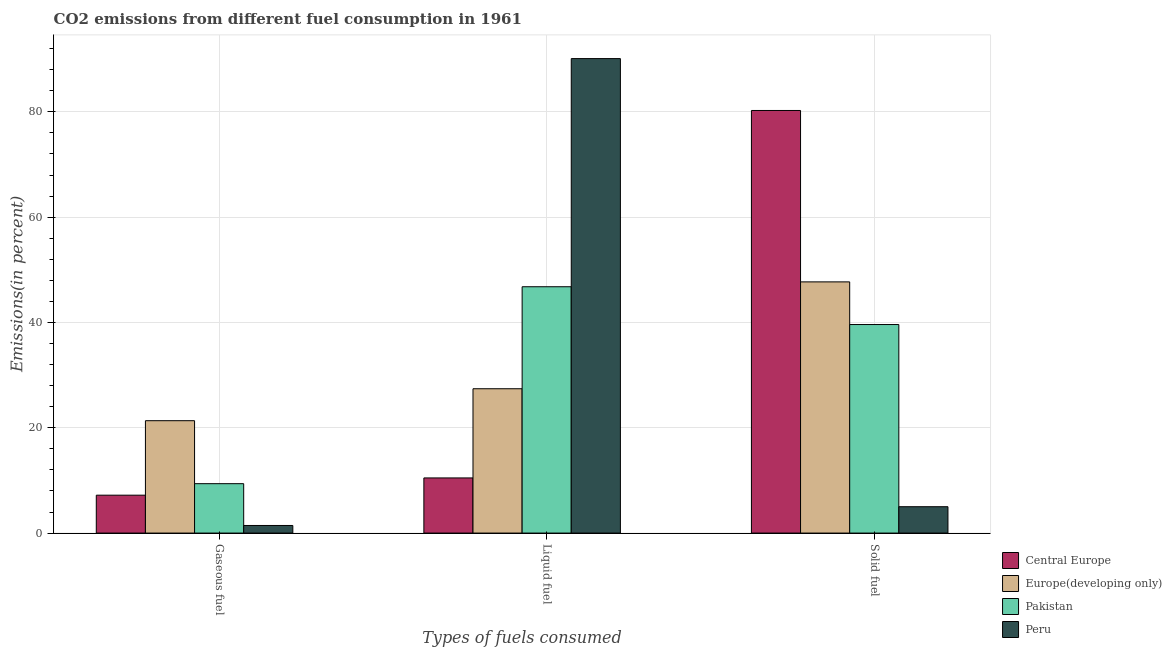How many different coloured bars are there?
Offer a terse response. 4. Are the number of bars on each tick of the X-axis equal?
Provide a short and direct response. Yes. How many bars are there on the 1st tick from the left?
Your response must be concise. 4. What is the label of the 2nd group of bars from the left?
Your answer should be compact. Liquid fuel. What is the percentage of solid fuel emission in Peru?
Make the answer very short. 5.01. Across all countries, what is the maximum percentage of solid fuel emission?
Ensure brevity in your answer.  80.26. Across all countries, what is the minimum percentage of liquid fuel emission?
Your answer should be compact. 10.47. In which country was the percentage of solid fuel emission maximum?
Your answer should be very brief. Central Europe. What is the total percentage of solid fuel emission in the graph?
Your answer should be very brief. 172.58. What is the difference between the percentage of gaseous fuel emission in Central Europe and that in Europe(developing only)?
Keep it short and to the point. -14.14. What is the difference between the percentage of solid fuel emission in Central Europe and the percentage of liquid fuel emission in Peru?
Offer a terse response. -9.85. What is the average percentage of liquid fuel emission per country?
Your response must be concise. 43.7. What is the difference between the percentage of gaseous fuel emission and percentage of solid fuel emission in Pakistan?
Your response must be concise. -30.22. What is the ratio of the percentage of gaseous fuel emission in Peru to that in Pakistan?
Your answer should be compact. 0.15. Is the difference between the percentage of liquid fuel emission in Europe(developing only) and Peru greater than the difference between the percentage of gaseous fuel emission in Europe(developing only) and Peru?
Provide a succinct answer. No. What is the difference between the highest and the second highest percentage of gaseous fuel emission?
Your answer should be compact. 11.96. What is the difference between the highest and the lowest percentage of gaseous fuel emission?
Your answer should be very brief. 19.9. What does the 4th bar from the right in Gaseous fuel represents?
Your answer should be compact. Central Europe. Is it the case that in every country, the sum of the percentage of gaseous fuel emission and percentage of liquid fuel emission is greater than the percentage of solid fuel emission?
Offer a very short reply. No. How many bars are there?
Offer a terse response. 12. How many countries are there in the graph?
Your response must be concise. 4. What is the difference between two consecutive major ticks on the Y-axis?
Give a very brief answer. 20. Are the values on the major ticks of Y-axis written in scientific E-notation?
Offer a terse response. No. How many legend labels are there?
Ensure brevity in your answer.  4. What is the title of the graph?
Keep it short and to the point. CO2 emissions from different fuel consumption in 1961. Does "Tajikistan" appear as one of the legend labels in the graph?
Offer a very short reply. No. What is the label or title of the X-axis?
Provide a succinct answer. Types of fuels consumed. What is the label or title of the Y-axis?
Your answer should be compact. Emissions(in percent). What is the Emissions(in percent) in Central Europe in Gaseous fuel?
Your answer should be very brief. 7.2. What is the Emissions(in percent) of Europe(developing only) in Gaseous fuel?
Provide a succinct answer. 21.34. What is the Emissions(in percent) of Pakistan in Gaseous fuel?
Offer a terse response. 9.38. What is the Emissions(in percent) in Peru in Gaseous fuel?
Provide a succinct answer. 1.44. What is the Emissions(in percent) of Central Europe in Liquid fuel?
Your answer should be very brief. 10.47. What is the Emissions(in percent) in Europe(developing only) in Liquid fuel?
Your answer should be very brief. 27.41. What is the Emissions(in percent) of Pakistan in Liquid fuel?
Offer a very short reply. 46.79. What is the Emissions(in percent) in Peru in Liquid fuel?
Offer a very short reply. 90.11. What is the Emissions(in percent) of Central Europe in Solid fuel?
Offer a very short reply. 80.26. What is the Emissions(in percent) in Europe(developing only) in Solid fuel?
Ensure brevity in your answer.  47.71. What is the Emissions(in percent) of Pakistan in Solid fuel?
Give a very brief answer. 39.6. What is the Emissions(in percent) of Peru in Solid fuel?
Give a very brief answer. 5.01. Across all Types of fuels consumed, what is the maximum Emissions(in percent) in Central Europe?
Your answer should be very brief. 80.26. Across all Types of fuels consumed, what is the maximum Emissions(in percent) in Europe(developing only)?
Provide a succinct answer. 47.71. Across all Types of fuels consumed, what is the maximum Emissions(in percent) in Pakistan?
Offer a very short reply. 46.79. Across all Types of fuels consumed, what is the maximum Emissions(in percent) of Peru?
Provide a succinct answer. 90.11. Across all Types of fuels consumed, what is the minimum Emissions(in percent) of Central Europe?
Your answer should be compact. 7.2. Across all Types of fuels consumed, what is the minimum Emissions(in percent) of Europe(developing only)?
Provide a short and direct response. 21.34. Across all Types of fuels consumed, what is the minimum Emissions(in percent) in Pakistan?
Give a very brief answer. 9.38. Across all Types of fuels consumed, what is the minimum Emissions(in percent) in Peru?
Provide a succinct answer. 1.44. What is the total Emissions(in percent) in Central Europe in the graph?
Ensure brevity in your answer.  97.93. What is the total Emissions(in percent) of Europe(developing only) in the graph?
Offer a terse response. 96.46. What is the total Emissions(in percent) in Pakistan in the graph?
Give a very brief answer. 95.77. What is the total Emissions(in percent) in Peru in the graph?
Offer a terse response. 96.56. What is the difference between the Emissions(in percent) in Central Europe in Gaseous fuel and that in Liquid fuel?
Your response must be concise. -3.28. What is the difference between the Emissions(in percent) of Europe(developing only) in Gaseous fuel and that in Liquid fuel?
Offer a terse response. -6.07. What is the difference between the Emissions(in percent) of Pakistan in Gaseous fuel and that in Liquid fuel?
Offer a terse response. -37.4. What is the difference between the Emissions(in percent) in Peru in Gaseous fuel and that in Liquid fuel?
Make the answer very short. -88.67. What is the difference between the Emissions(in percent) of Central Europe in Gaseous fuel and that in Solid fuel?
Offer a terse response. -73.07. What is the difference between the Emissions(in percent) of Europe(developing only) in Gaseous fuel and that in Solid fuel?
Provide a short and direct response. -26.37. What is the difference between the Emissions(in percent) in Pakistan in Gaseous fuel and that in Solid fuel?
Keep it short and to the point. -30.22. What is the difference between the Emissions(in percent) in Peru in Gaseous fuel and that in Solid fuel?
Provide a succinct answer. -3.56. What is the difference between the Emissions(in percent) in Central Europe in Liquid fuel and that in Solid fuel?
Keep it short and to the point. -69.79. What is the difference between the Emissions(in percent) of Europe(developing only) in Liquid fuel and that in Solid fuel?
Your answer should be compact. -20.3. What is the difference between the Emissions(in percent) of Pakistan in Liquid fuel and that in Solid fuel?
Your answer should be very brief. 7.18. What is the difference between the Emissions(in percent) in Peru in Liquid fuel and that in Solid fuel?
Your response must be concise. 85.11. What is the difference between the Emissions(in percent) in Central Europe in Gaseous fuel and the Emissions(in percent) in Europe(developing only) in Liquid fuel?
Give a very brief answer. -20.21. What is the difference between the Emissions(in percent) of Central Europe in Gaseous fuel and the Emissions(in percent) of Pakistan in Liquid fuel?
Ensure brevity in your answer.  -39.59. What is the difference between the Emissions(in percent) of Central Europe in Gaseous fuel and the Emissions(in percent) of Peru in Liquid fuel?
Your answer should be compact. -82.92. What is the difference between the Emissions(in percent) of Europe(developing only) in Gaseous fuel and the Emissions(in percent) of Pakistan in Liquid fuel?
Make the answer very short. -25.44. What is the difference between the Emissions(in percent) in Europe(developing only) in Gaseous fuel and the Emissions(in percent) in Peru in Liquid fuel?
Give a very brief answer. -68.77. What is the difference between the Emissions(in percent) in Pakistan in Gaseous fuel and the Emissions(in percent) in Peru in Liquid fuel?
Provide a succinct answer. -80.73. What is the difference between the Emissions(in percent) of Central Europe in Gaseous fuel and the Emissions(in percent) of Europe(developing only) in Solid fuel?
Make the answer very short. -40.51. What is the difference between the Emissions(in percent) in Central Europe in Gaseous fuel and the Emissions(in percent) in Pakistan in Solid fuel?
Make the answer very short. -32.41. What is the difference between the Emissions(in percent) of Central Europe in Gaseous fuel and the Emissions(in percent) of Peru in Solid fuel?
Give a very brief answer. 2.19. What is the difference between the Emissions(in percent) of Europe(developing only) in Gaseous fuel and the Emissions(in percent) of Pakistan in Solid fuel?
Provide a short and direct response. -18.26. What is the difference between the Emissions(in percent) of Europe(developing only) in Gaseous fuel and the Emissions(in percent) of Peru in Solid fuel?
Give a very brief answer. 16.34. What is the difference between the Emissions(in percent) of Pakistan in Gaseous fuel and the Emissions(in percent) of Peru in Solid fuel?
Ensure brevity in your answer.  4.38. What is the difference between the Emissions(in percent) in Central Europe in Liquid fuel and the Emissions(in percent) in Europe(developing only) in Solid fuel?
Offer a terse response. -37.23. What is the difference between the Emissions(in percent) in Central Europe in Liquid fuel and the Emissions(in percent) in Pakistan in Solid fuel?
Keep it short and to the point. -29.13. What is the difference between the Emissions(in percent) in Central Europe in Liquid fuel and the Emissions(in percent) in Peru in Solid fuel?
Ensure brevity in your answer.  5.47. What is the difference between the Emissions(in percent) in Europe(developing only) in Liquid fuel and the Emissions(in percent) in Pakistan in Solid fuel?
Offer a very short reply. -12.19. What is the difference between the Emissions(in percent) in Europe(developing only) in Liquid fuel and the Emissions(in percent) in Peru in Solid fuel?
Your answer should be compact. 22.4. What is the difference between the Emissions(in percent) in Pakistan in Liquid fuel and the Emissions(in percent) in Peru in Solid fuel?
Offer a terse response. 41.78. What is the average Emissions(in percent) of Central Europe per Types of fuels consumed?
Make the answer very short. 32.64. What is the average Emissions(in percent) in Europe(developing only) per Types of fuels consumed?
Give a very brief answer. 32.15. What is the average Emissions(in percent) of Pakistan per Types of fuels consumed?
Provide a succinct answer. 31.92. What is the average Emissions(in percent) in Peru per Types of fuels consumed?
Make the answer very short. 32.19. What is the difference between the Emissions(in percent) in Central Europe and Emissions(in percent) in Europe(developing only) in Gaseous fuel?
Provide a succinct answer. -14.14. What is the difference between the Emissions(in percent) in Central Europe and Emissions(in percent) in Pakistan in Gaseous fuel?
Ensure brevity in your answer.  -2.18. What is the difference between the Emissions(in percent) in Central Europe and Emissions(in percent) in Peru in Gaseous fuel?
Ensure brevity in your answer.  5.75. What is the difference between the Emissions(in percent) of Europe(developing only) and Emissions(in percent) of Pakistan in Gaseous fuel?
Ensure brevity in your answer.  11.96. What is the difference between the Emissions(in percent) of Europe(developing only) and Emissions(in percent) of Peru in Gaseous fuel?
Your answer should be very brief. 19.9. What is the difference between the Emissions(in percent) of Pakistan and Emissions(in percent) of Peru in Gaseous fuel?
Give a very brief answer. 7.94. What is the difference between the Emissions(in percent) of Central Europe and Emissions(in percent) of Europe(developing only) in Liquid fuel?
Ensure brevity in your answer.  -16.94. What is the difference between the Emissions(in percent) in Central Europe and Emissions(in percent) in Pakistan in Liquid fuel?
Ensure brevity in your answer.  -36.31. What is the difference between the Emissions(in percent) in Central Europe and Emissions(in percent) in Peru in Liquid fuel?
Keep it short and to the point. -79.64. What is the difference between the Emissions(in percent) of Europe(developing only) and Emissions(in percent) of Pakistan in Liquid fuel?
Offer a very short reply. -19.37. What is the difference between the Emissions(in percent) of Europe(developing only) and Emissions(in percent) of Peru in Liquid fuel?
Give a very brief answer. -62.7. What is the difference between the Emissions(in percent) in Pakistan and Emissions(in percent) in Peru in Liquid fuel?
Offer a terse response. -43.33. What is the difference between the Emissions(in percent) of Central Europe and Emissions(in percent) of Europe(developing only) in Solid fuel?
Keep it short and to the point. 32.56. What is the difference between the Emissions(in percent) of Central Europe and Emissions(in percent) of Pakistan in Solid fuel?
Your answer should be compact. 40.66. What is the difference between the Emissions(in percent) of Central Europe and Emissions(in percent) of Peru in Solid fuel?
Your response must be concise. 75.26. What is the difference between the Emissions(in percent) in Europe(developing only) and Emissions(in percent) in Pakistan in Solid fuel?
Ensure brevity in your answer.  8.1. What is the difference between the Emissions(in percent) of Europe(developing only) and Emissions(in percent) of Peru in Solid fuel?
Your response must be concise. 42.7. What is the difference between the Emissions(in percent) of Pakistan and Emissions(in percent) of Peru in Solid fuel?
Provide a succinct answer. 34.6. What is the ratio of the Emissions(in percent) of Central Europe in Gaseous fuel to that in Liquid fuel?
Provide a succinct answer. 0.69. What is the ratio of the Emissions(in percent) of Europe(developing only) in Gaseous fuel to that in Liquid fuel?
Provide a succinct answer. 0.78. What is the ratio of the Emissions(in percent) in Pakistan in Gaseous fuel to that in Liquid fuel?
Offer a very short reply. 0.2. What is the ratio of the Emissions(in percent) in Peru in Gaseous fuel to that in Liquid fuel?
Ensure brevity in your answer.  0.02. What is the ratio of the Emissions(in percent) in Central Europe in Gaseous fuel to that in Solid fuel?
Your answer should be very brief. 0.09. What is the ratio of the Emissions(in percent) of Europe(developing only) in Gaseous fuel to that in Solid fuel?
Provide a succinct answer. 0.45. What is the ratio of the Emissions(in percent) in Pakistan in Gaseous fuel to that in Solid fuel?
Give a very brief answer. 0.24. What is the ratio of the Emissions(in percent) in Peru in Gaseous fuel to that in Solid fuel?
Give a very brief answer. 0.29. What is the ratio of the Emissions(in percent) of Central Europe in Liquid fuel to that in Solid fuel?
Keep it short and to the point. 0.13. What is the ratio of the Emissions(in percent) of Europe(developing only) in Liquid fuel to that in Solid fuel?
Offer a terse response. 0.57. What is the ratio of the Emissions(in percent) of Pakistan in Liquid fuel to that in Solid fuel?
Keep it short and to the point. 1.18. What is the ratio of the Emissions(in percent) of Peru in Liquid fuel to that in Solid fuel?
Provide a succinct answer. 18. What is the difference between the highest and the second highest Emissions(in percent) of Central Europe?
Keep it short and to the point. 69.79. What is the difference between the highest and the second highest Emissions(in percent) of Europe(developing only)?
Give a very brief answer. 20.3. What is the difference between the highest and the second highest Emissions(in percent) of Pakistan?
Your answer should be compact. 7.18. What is the difference between the highest and the second highest Emissions(in percent) in Peru?
Offer a terse response. 85.11. What is the difference between the highest and the lowest Emissions(in percent) of Central Europe?
Provide a succinct answer. 73.07. What is the difference between the highest and the lowest Emissions(in percent) in Europe(developing only)?
Your answer should be very brief. 26.37. What is the difference between the highest and the lowest Emissions(in percent) in Pakistan?
Your answer should be very brief. 37.4. What is the difference between the highest and the lowest Emissions(in percent) of Peru?
Keep it short and to the point. 88.67. 